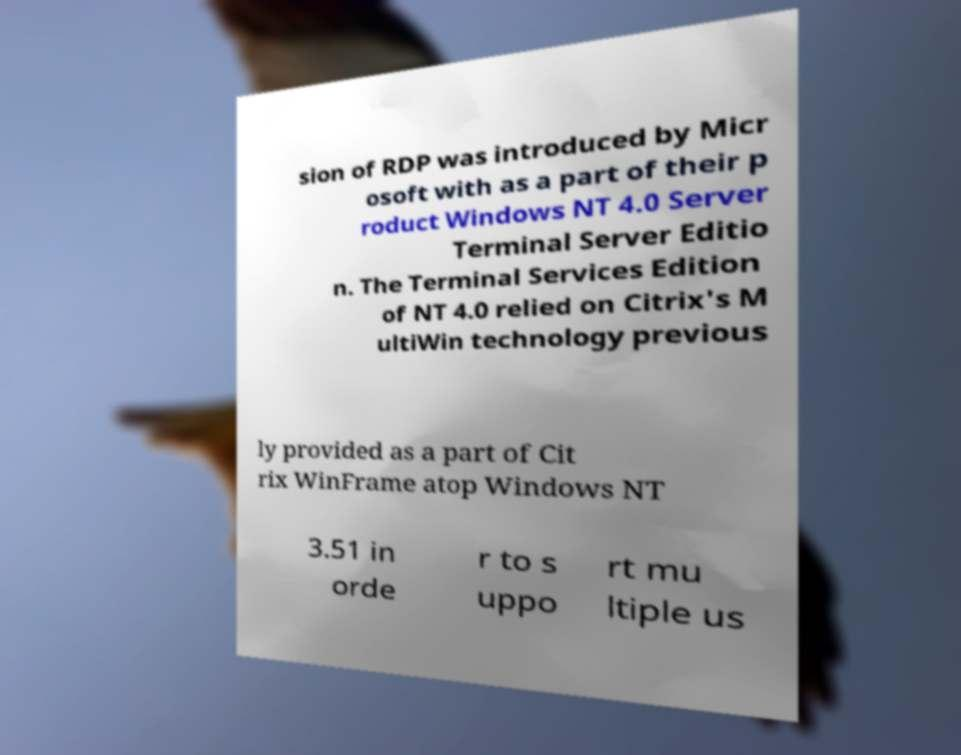What messages or text are displayed in this image? I need them in a readable, typed format. sion of RDP was introduced by Micr osoft with as a part of their p roduct Windows NT 4.0 Server Terminal Server Editio n. The Terminal Services Edition of NT 4.0 relied on Citrix's M ultiWin technology previous ly provided as a part of Cit rix WinFrame atop Windows NT 3.51 in orde r to s uppo rt mu ltiple us 